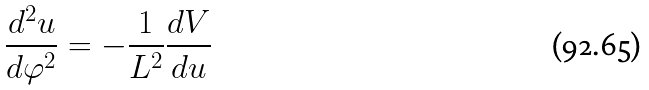<formula> <loc_0><loc_0><loc_500><loc_500>\frac { d ^ { 2 } u } { d \varphi ^ { 2 } } = - \frac { 1 } { L ^ { 2 } } \frac { d V } { d u }</formula> 